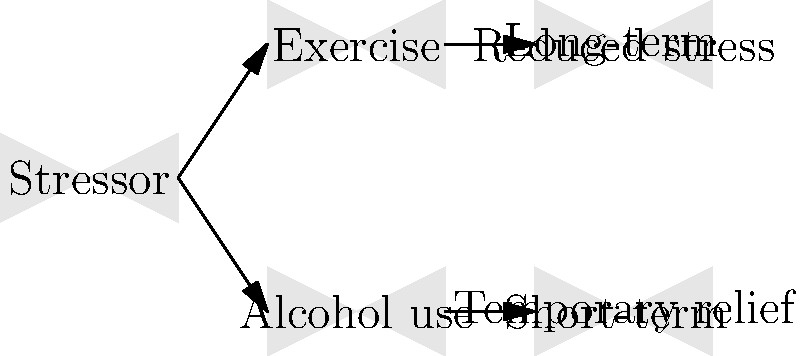Based on the behavior flow chart, which coping mechanism is more effective for long-term stress reduction? To determine the more effective coping mechanism for long-term stress reduction, let's analyze the flow chart step-by-step:

1. The chart starts with a "Stressor" as the initial trigger.

2. Two potential coping mechanisms are presented:
   a) Exercise
   b) Alcohol use

3. For Exercise:
   - The arrow leads to "Reduced stress"
   - The arrow is labeled "Long-term"

4. For Alcohol use:
   - The arrow leads to "Temporary relief"
   - The arrow is labeled "Short-term"

5. Comparing the outcomes:
   - Exercise results in "Reduced stress" with a long-term effect
   - Alcohol use results in "Temporary relief" with a short-term effect

6. In the context of effective coping mechanisms:
   - Long-term solutions are generally more beneficial for overall well-being
   - Temporary relief may lead to recurring stress and potential negative side effects

Therefore, based on the flow chart, exercise is the more effective coping mechanism for long-term stress reduction. It provides a sustained reduction in stress levels, while alcohol use only offers temporary relief and may lead to additional problems in the long run.
Answer: Exercise 